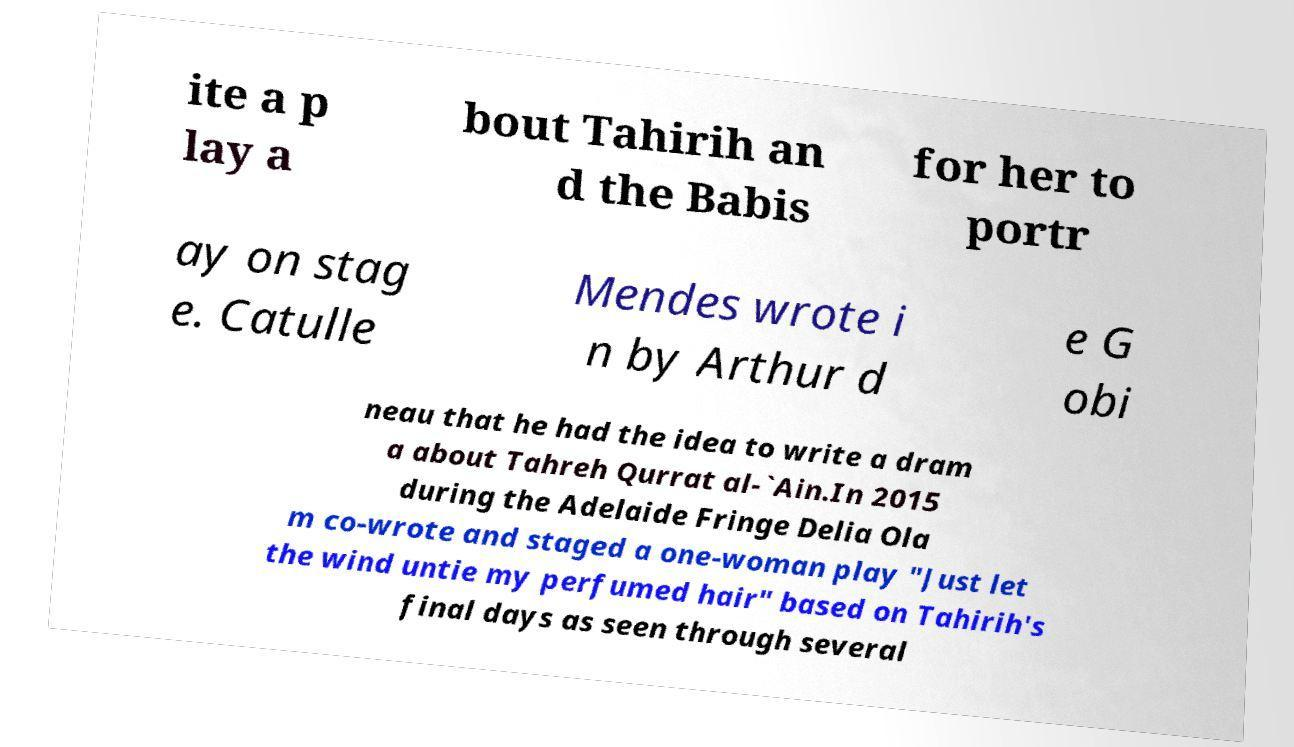Please identify and transcribe the text found in this image. ite a p lay a bout Tahirih an d the Babis for her to portr ay on stag e. Catulle Mendes wrote i n by Arthur d e G obi neau that he had the idea to write a dram a about Tahreh Qurrat al-`Ain.In 2015 during the Adelaide Fringe Delia Ola m co-wrote and staged a one-woman play "Just let the wind untie my perfumed hair" based on Tahirih's final days as seen through several 